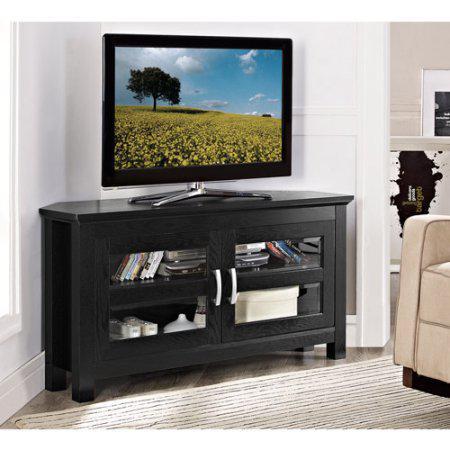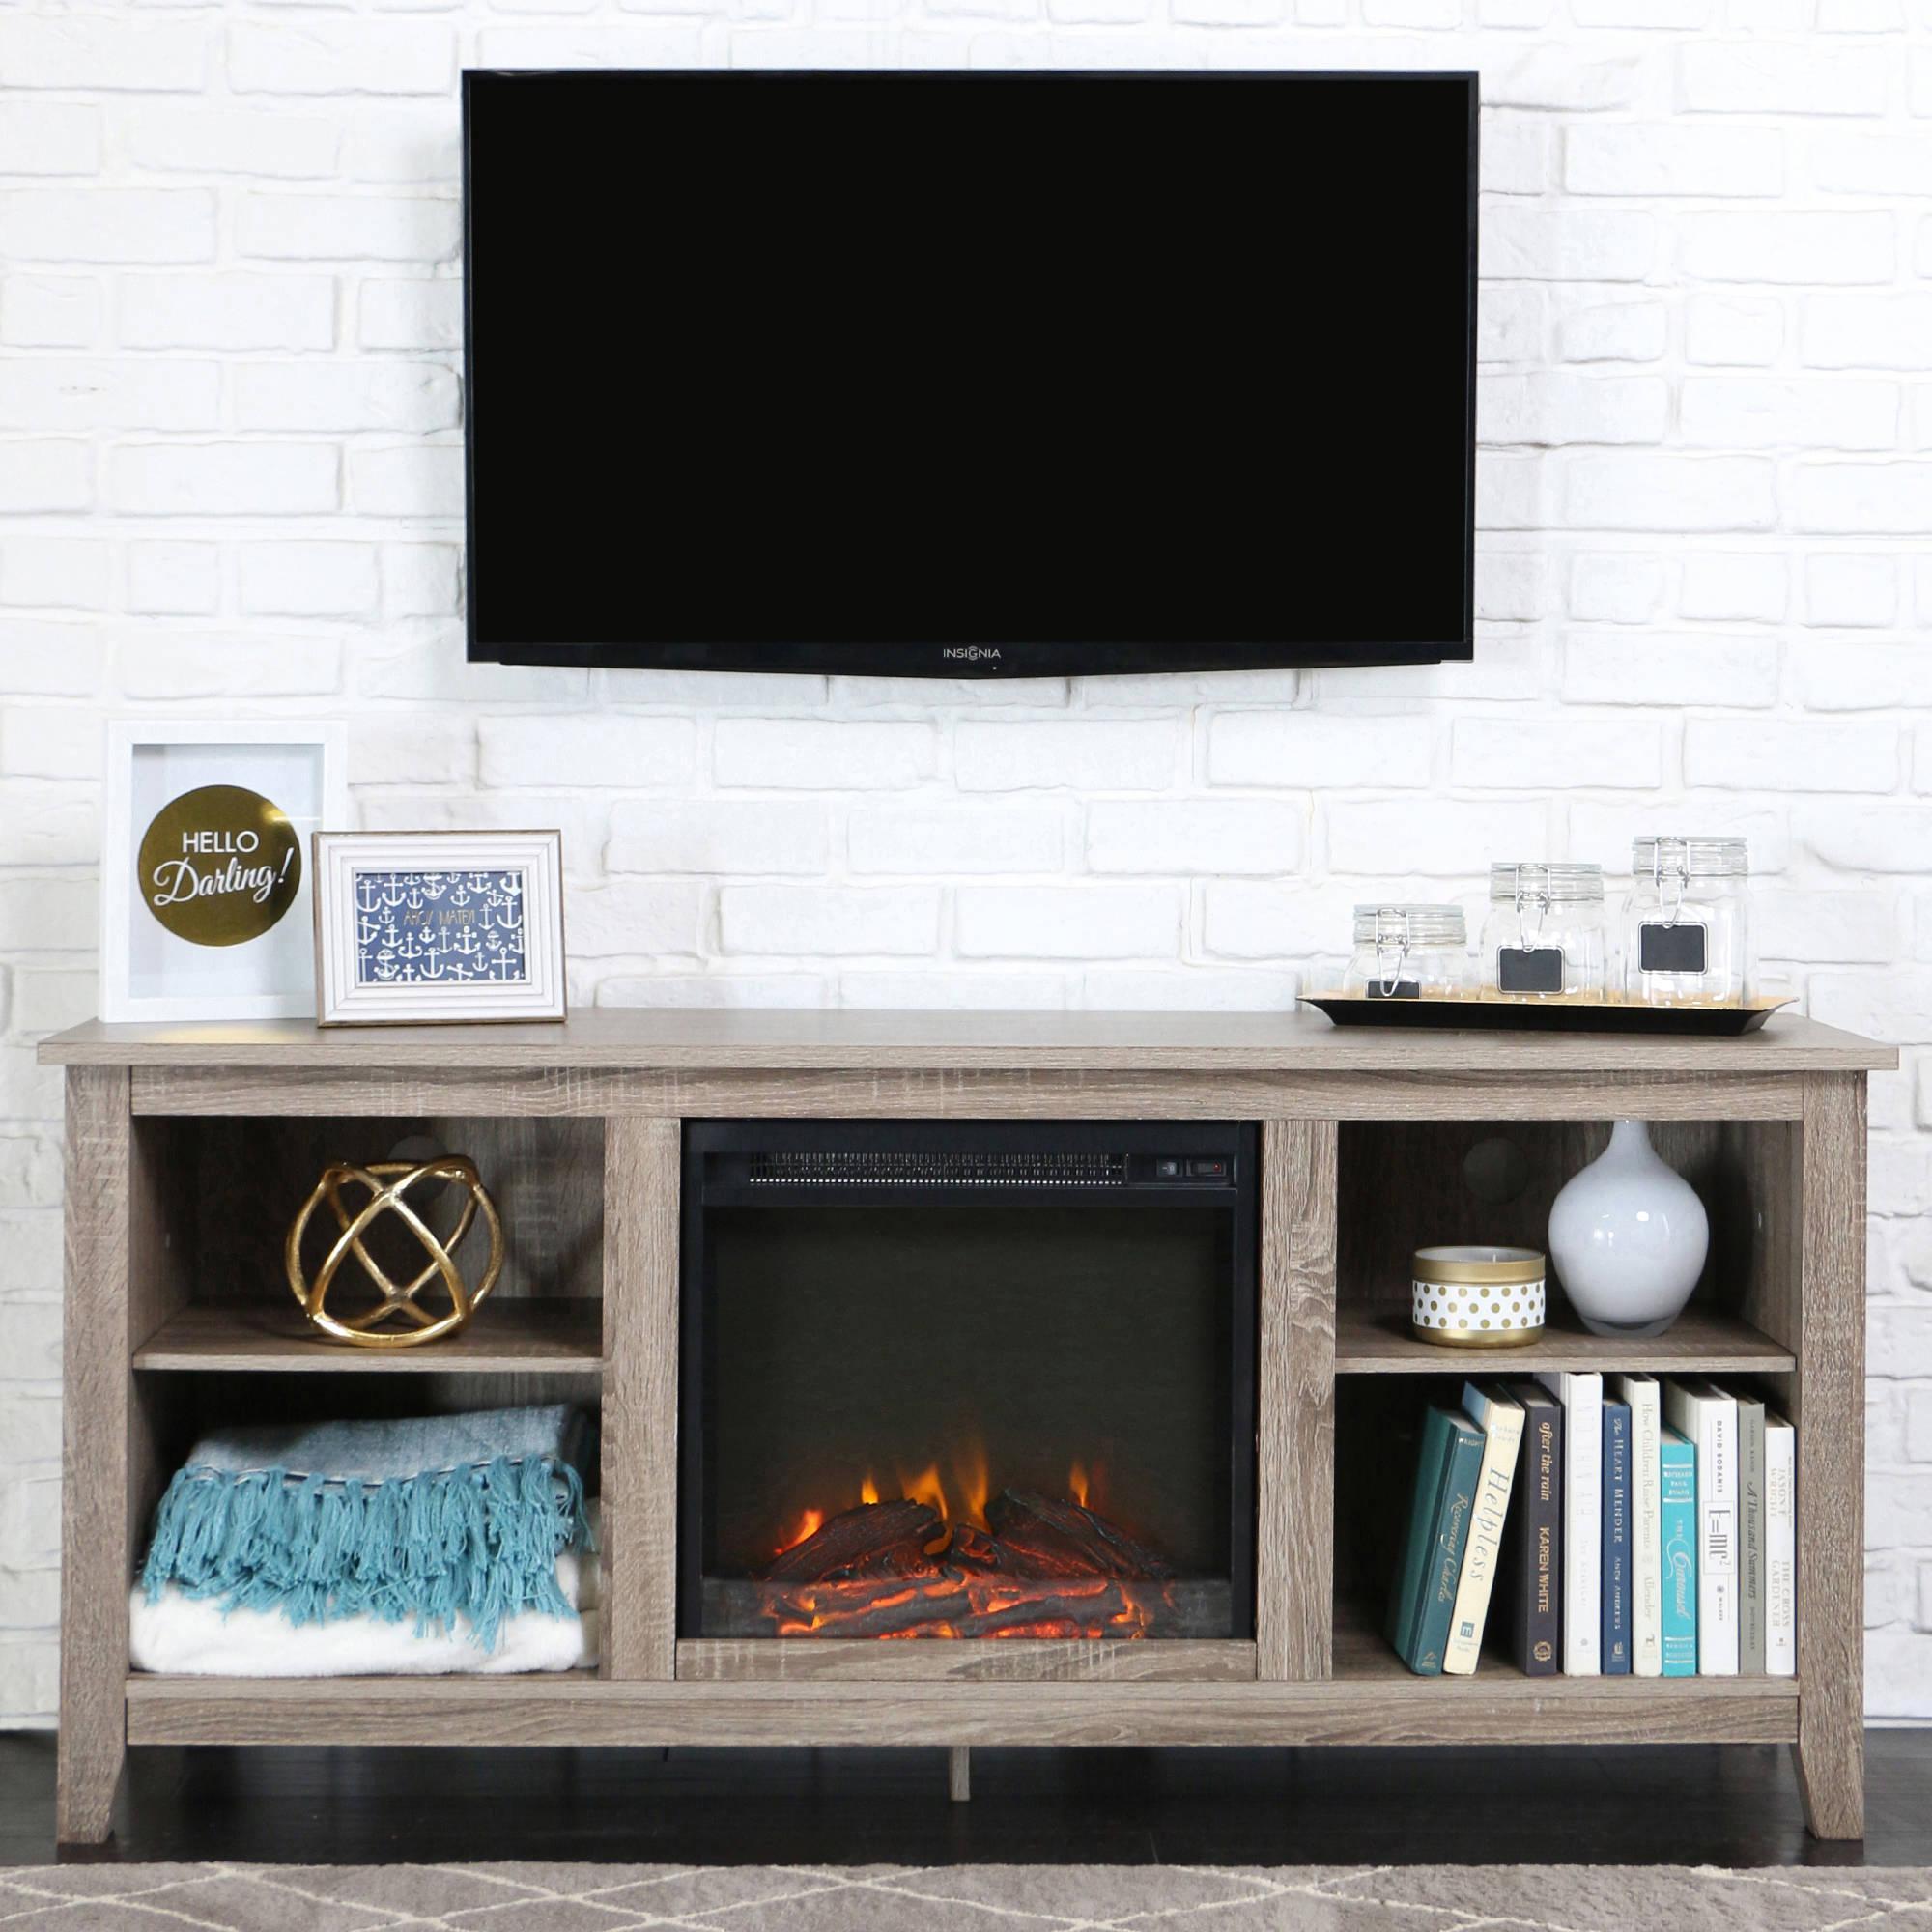The first image is the image on the left, the second image is the image on the right. For the images shown, is this caption "There are more screens in the left image than in the right image." true? Answer yes or no. No. The first image is the image on the left, the second image is the image on the right. Evaluate the accuracy of this statement regarding the images: "There are multiple monitors in one image, and a TV on a stand in the other image.". Is it true? Answer yes or no. No. 